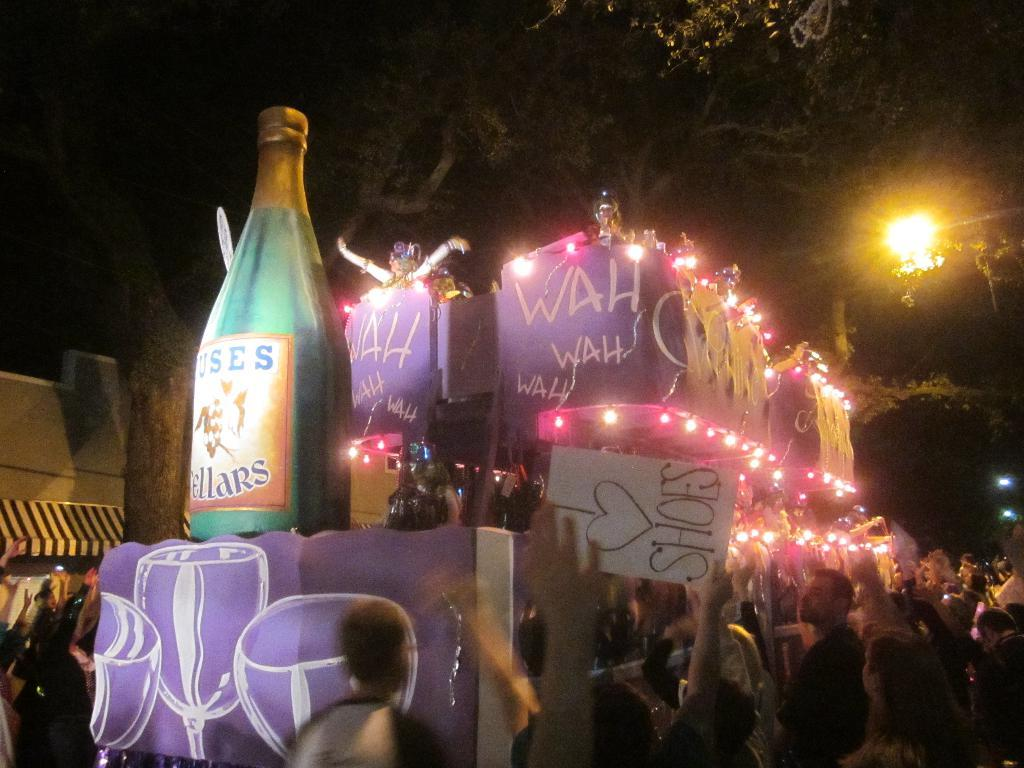<image>
Present a compact description of the photo's key features. Someone holds a sign up that says I love shoes. 